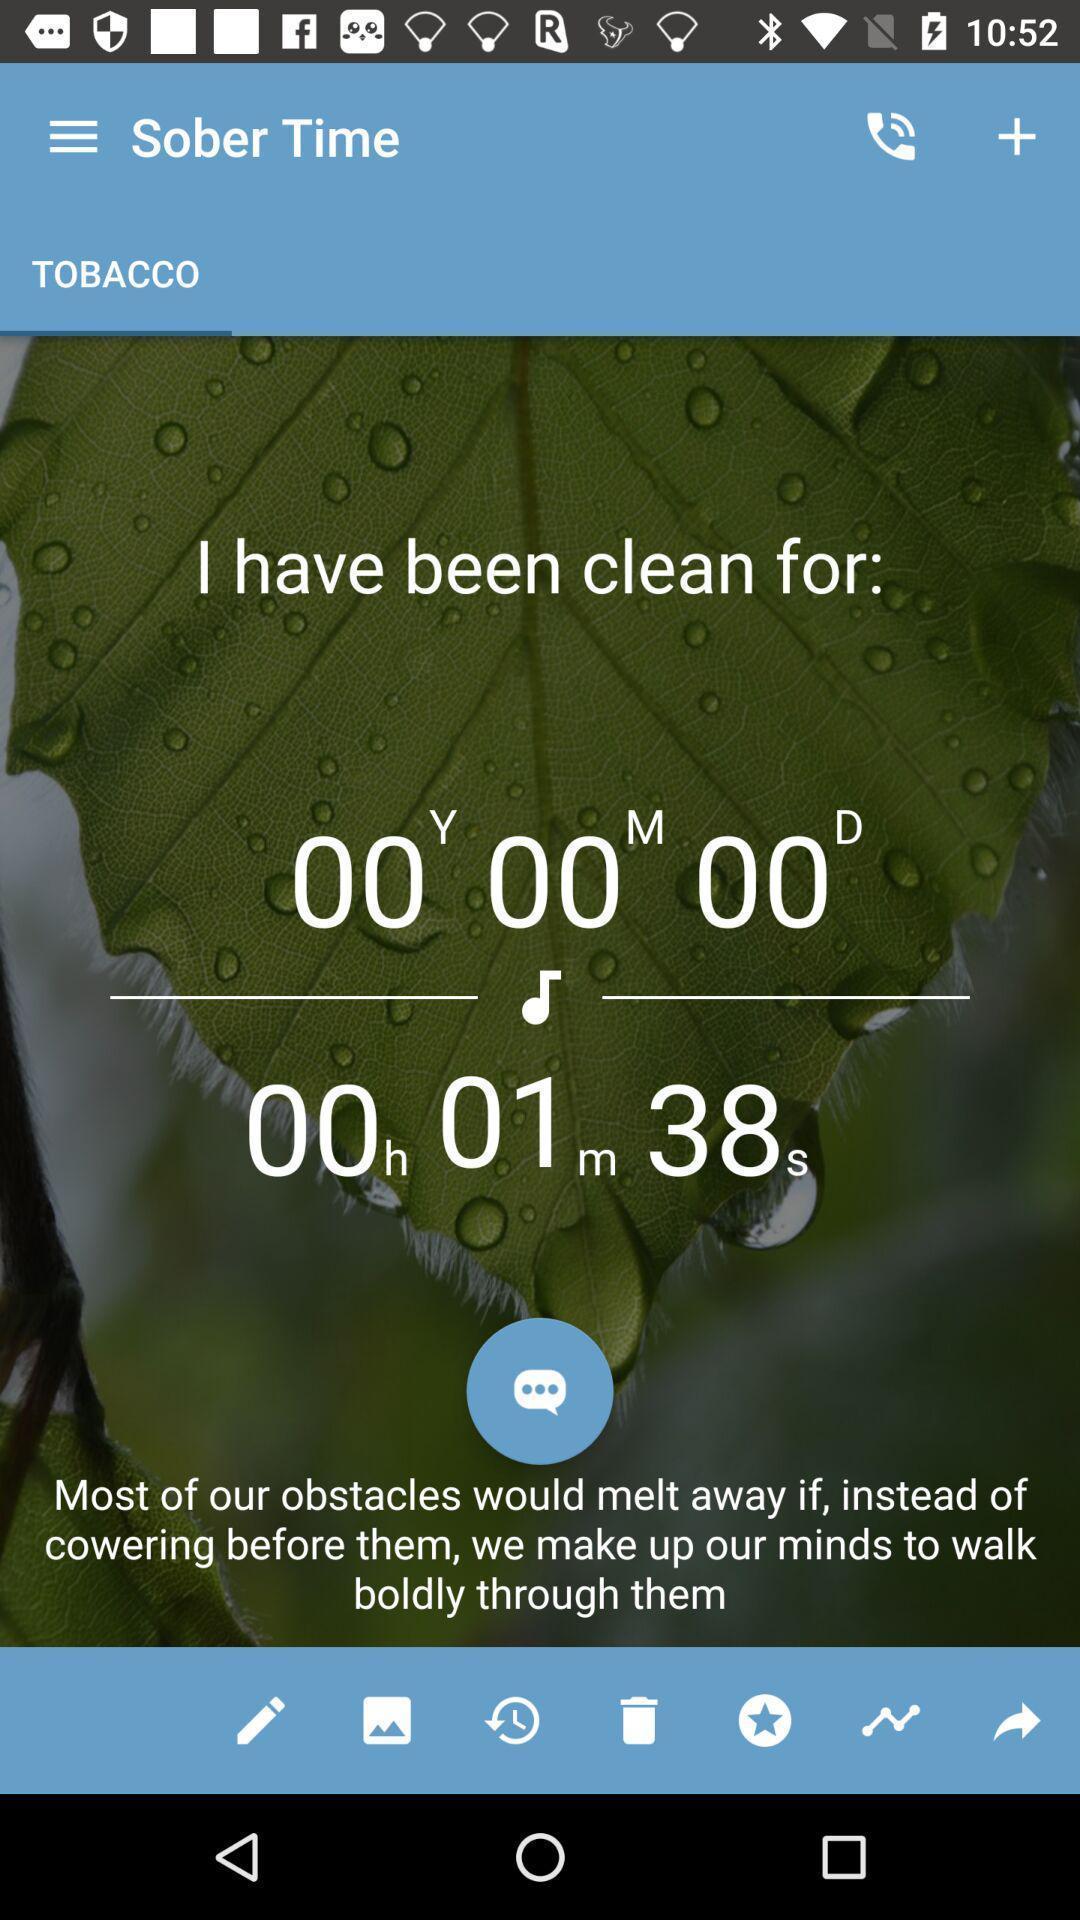Explain the elements present in this screenshot. Page shows about sober time. 